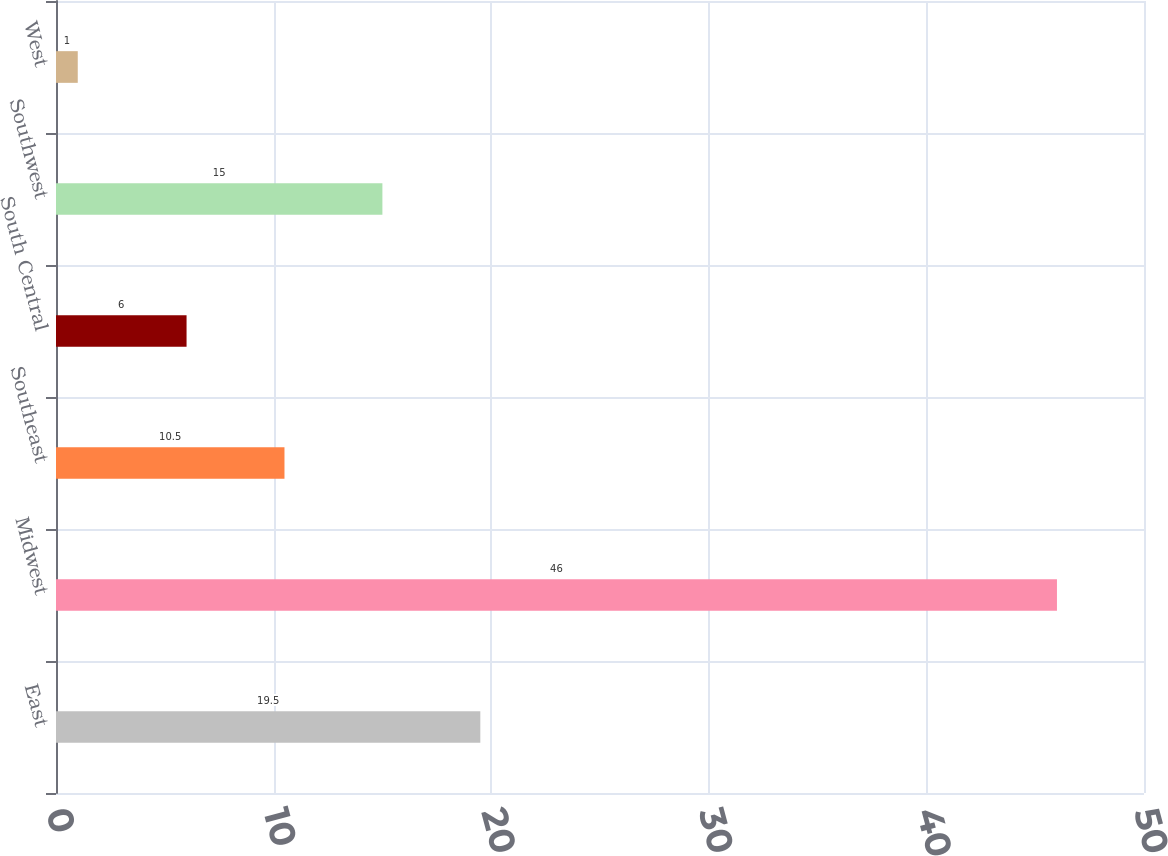Convert chart. <chart><loc_0><loc_0><loc_500><loc_500><bar_chart><fcel>East<fcel>Midwest<fcel>Southeast<fcel>South Central<fcel>Southwest<fcel>West<nl><fcel>19.5<fcel>46<fcel>10.5<fcel>6<fcel>15<fcel>1<nl></chart> 